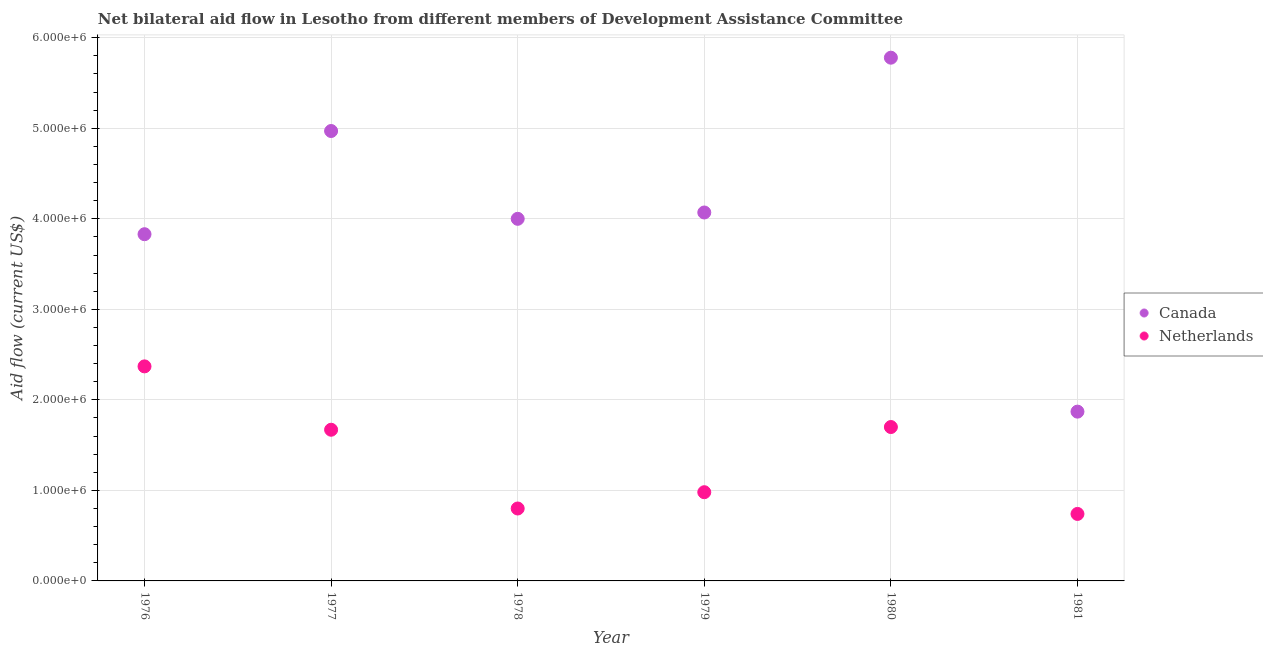How many different coloured dotlines are there?
Give a very brief answer. 2. Is the number of dotlines equal to the number of legend labels?
Your answer should be compact. Yes. What is the amount of aid given by netherlands in 1981?
Offer a very short reply. 7.40e+05. Across all years, what is the maximum amount of aid given by canada?
Your answer should be compact. 5.78e+06. Across all years, what is the minimum amount of aid given by canada?
Offer a very short reply. 1.87e+06. In which year was the amount of aid given by canada maximum?
Your response must be concise. 1980. In which year was the amount of aid given by netherlands minimum?
Your answer should be very brief. 1981. What is the total amount of aid given by netherlands in the graph?
Offer a terse response. 8.26e+06. What is the difference between the amount of aid given by netherlands in 1980 and that in 1981?
Your response must be concise. 9.60e+05. What is the difference between the amount of aid given by netherlands in 1979 and the amount of aid given by canada in 1976?
Provide a succinct answer. -2.85e+06. What is the average amount of aid given by canada per year?
Keep it short and to the point. 4.09e+06. In the year 1978, what is the difference between the amount of aid given by netherlands and amount of aid given by canada?
Your answer should be compact. -3.20e+06. In how many years, is the amount of aid given by canada greater than 4800000 US$?
Make the answer very short. 2. What is the ratio of the amount of aid given by netherlands in 1976 to that in 1979?
Offer a terse response. 2.42. Is the amount of aid given by netherlands in 1977 less than that in 1978?
Your answer should be compact. No. Is the difference between the amount of aid given by canada in 1980 and 1981 greater than the difference between the amount of aid given by netherlands in 1980 and 1981?
Your answer should be very brief. Yes. What is the difference between the highest and the second highest amount of aid given by canada?
Your answer should be very brief. 8.10e+05. What is the difference between the highest and the lowest amount of aid given by canada?
Ensure brevity in your answer.  3.91e+06. Are the values on the major ticks of Y-axis written in scientific E-notation?
Your answer should be compact. Yes. Does the graph contain any zero values?
Your answer should be compact. No. Where does the legend appear in the graph?
Your response must be concise. Center right. How are the legend labels stacked?
Offer a very short reply. Vertical. What is the title of the graph?
Keep it short and to the point. Net bilateral aid flow in Lesotho from different members of Development Assistance Committee. What is the label or title of the X-axis?
Keep it short and to the point. Year. What is the label or title of the Y-axis?
Your response must be concise. Aid flow (current US$). What is the Aid flow (current US$) of Canada in 1976?
Ensure brevity in your answer.  3.83e+06. What is the Aid flow (current US$) of Netherlands in 1976?
Your answer should be very brief. 2.37e+06. What is the Aid flow (current US$) in Canada in 1977?
Your answer should be very brief. 4.97e+06. What is the Aid flow (current US$) in Netherlands in 1977?
Your answer should be very brief. 1.67e+06. What is the Aid flow (current US$) of Canada in 1978?
Provide a succinct answer. 4.00e+06. What is the Aid flow (current US$) in Netherlands in 1978?
Ensure brevity in your answer.  8.00e+05. What is the Aid flow (current US$) in Canada in 1979?
Offer a very short reply. 4.07e+06. What is the Aid flow (current US$) in Netherlands in 1979?
Provide a short and direct response. 9.80e+05. What is the Aid flow (current US$) of Canada in 1980?
Ensure brevity in your answer.  5.78e+06. What is the Aid flow (current US$) in Netherlands in 1980?
Ensure brevity in your answer.  1.70e+06. What is the Aid flow (current US$) of Canada in 1981?
Give a very brief answer. 1.87e+06. What is the Aid flow (current US$) of Netherlands in 1981?
Provide a succinct answer. 7.40e+05. Across all years, what is the maximum Aid flow (current US$) in Canada?
Provide a succinct answer. 5.78e+06. Across all years, what is the maximum Aid flow (current US$) of Netherlands?
Make the answer very short. 2.37e+06. Across all years, what is the minimum Aid flow (current US$) in Canada?
Give a very brief answer. 1.87e+06. Across all years, what is the minimum Aid flow (current US$) in Netherlands?
Provide a short and direct response. 7.40e+05. What is the total Aid flow (current US$) of Canada in the graph?
Offer a very short reply. 2.45e+07. What is the total Aid flow (current US$) in Netherlands in the graph?
Give a very brief answer. 8.26e+06. What is the difference between the Aid flow (current US$) of Canada in 1976 and that in 1977?
Ensure brevity in your answer.  -1.14e+06. What is the difference between the Aid flow (current US$) of Netherlands in 1976 and that in 1977?
Give a very brief answer. 7.00e+05. What is the difference between the Aid flow (current US$) of Netherlands in 1976 and that in 1978?
Your answer should be very brief. 1.57e+06. What is the difference between the Aid flow (current US$) of Netherlands in 1976 and that in 1979?
Your answer should be compact. 1.39e+06. What is the difference between the Aid flow (current US$) in Canada in 1976 and that in 1980?
Make the answer very short. -1.95e+06. What is the difference between the Aid flow (current US$) of Netherlands in 1976 and that in 1980?
Ensure brevity in your answer.  6.70e+05. What is the difference between the Aid flow (current US$) of Canada in 1976 and that in 1981?
Your answer should be very brief. 1.96e+06. What is the difference between the Aid flow (current US$) of Netherlands in 1976 and that in 1981?
Your answer should be very brief. 1.63e+06. What is the difference between the Aid flow (current US$) in Canada in 1977 and that in 1978?
Provide a succinct answer. 9.70e+05. What is the difference between the Aid flow (current US$) in Netherlands in 1977 and that in 1978?
Offer a very short reply. 8.70e+05. What is the difference between the Aid flow (current US$) in Netherlands in 1977 and that in 1979?
Your answer should be very brief. 6.90e+05. What is the difference between the Aid flow (current US$) of Canada in 1977 and that in 1980?
Offer a very short reply. -8.10e+05. What is the difference between the Aid flow (current US$) in Netherlands in 1977 and that in 1980?
Keep it short and to the point. -3.00e+04. What is the difference between the Aid flow (current US$) of Canada in 1977 and that in 1981?
Give a very brief answer. 3.10e+06. What is the difference between the Aid flow (current US$) in Netherlands in 1977 and that in 1981?
Give a very brief answer. 9.30e+05. What is the difference between the Aid flow (current US$) of Canada in 1978 and that in 1979?
Your response must be concise. -7.00e+04. What is the difference between the Aid flow (current US$) in Netherlands in 1978 and that in 1979?
Make the answer very short. -1.80e+05. What is the difference between the Aid flow (current US$) in Canada in 1978 and that in 1980?
Offer a terse response. -1.78e+06. What is the difference between the Aid flow (current US$) in Netherlands in 1978 and that in 1980?
Make the answer very short. -9.00e+05. What is the difference between the Aid flow (current US$) in Canada in 1978 and that in 1981?
Your answer should be compact. 2.13e+06. What is the difference between the Aid flow (current US$) in Canada in 1979 and that in 1980?
Your answer should be compact. -1.71e+06. What is the difference between the Aid flow (current US$) in Netherlands in 1979 and that in 1980?
Offer a very short reply. -7.20e+05. What is the difference between the Aid flow (current US$) in Canada in 1979 and that in 1981?
Give a very brief answer. 2.20e+06. What is the difference between the Aid flow (current US$) of Netherlands in 1979 and that in 1981?
Keep it short and to the point. 2.40e+05. What is the difference between the Aid flow (current US$) of Canada in 1980 and that in 1981?
Your answer should be compact. 3.91e+06. What is the difference between the Aid flow (current US$) of Netherlands in 1980 and that in 1981?
Your answer should be compact. 9.60e+05. What is the difference between the Aid flow (current US$) in Canada in 1976 and the Aid flow (current US$) in Netherlands in 1977?
Your answer should be compact. 2.16e+06. What is the difference between the Aid flow (current US$) in Canada in 1976 and the Aid flow (current US$) in Netherlands in 1978?
Provide a short and direct response. 3.03e+06. What is the difference between the Aid flow (current US$) of Canada in 1976 and the Aid flow (current US$) of Netherlands in 1979?
Your answer should be compact. 2.85e+06. What is the difference between the Aid flow (current US$) of Canada in 1976 and the Aid flow (current US$) of Netherlands in 1980?
Give a very brief answer. 2.13e+06. What is the difference between the Aid flow (current US$) in Canada in 1976 and the Aid flow (current US$) in Netherlands in 1981?
Your answer should be very brief. 3.09e+06. What is the difference between the Aid flow (current US$) in Canada in 1977 and the Aid flow (current US$) in Netherlands in 1978?
Provide a short and direct response. 4.17e+06. What is the difference between the Aid flow (current US$) of Canada in 1977 and the Aid flow (current US$) of Netherlands in 1979?
Give a very brief answer. 3.99e+06. What is the difference between the Aid flow (current US$) in Canada in 1977 and the Aid flow (current US$) in Netherlands in 1980?
Provide a succinct answer. 3.27e+06. What is the difference between the Aid flow (current US$) in Canada in 1977 and the Aid flow (current US$) in Netherlands in 1981?
Make the answer very short. 4.23e+06. What is the difference between the Aid flow (current US$) in Canada in 1978 and the Aid flow (current US$) in Netherlands in 1979?
Offer a terse response. 3.02e+06. What is the difference between the Aid flow (current US$) in Canada in 1978 and the Aid flow (current US$) in Netherlands in 1980?
Your answer should be compact. 2.30e+06. What is the difference between the Aid flow (current US$) in Canada in 1978 and the Aid flow (current US$) in Netherlands in 1981?
Your answer should be compact. 3.26e+06. What is the difference between the Aid flow (current US$) in Canada in 1979 and the Aid flow (current US$) in Netherlands in 1980?
Your answer should be very brief. 2.37e+06. What is the difference between the Aid flow (current US$) of Canada in 1979 and the Aid flow (current US$) of Netherlands in 1981?
Give a very brief answer. 3.33e+06. What is the difference between the Aid flow (current US$) of Canada in 1980 and the Aid flow (current US$) of Netherlands in 1981?
Provide a short and direct response. 5.04e+06. What is the average Aid flow (current US$) in Canada per year?
Give a very brief answer. 4.09e+06. What is the average Aid flow (current US$) of Netherlands per year?
Ensure brevity in your answer.  1.38e+06. In the year 1976, what is the difference between the Aid flow (current US$) of Canada and Aid flow (current US$) of Netherlands?
Your response must be concise. 1.46e+06. In the year 1977, what is the difference between the Aid flow (current US$) of Canada and Aid flow (current US$) of Netherlands?
Keep it short and to the point. 3.30e+06. In the year 1978, what is the difference between the Aid flow (current US$) in Canada and Aid flow (current US$) in Netherlands?
Provide a short and direct response. 3.20e+06. In the year 1979, what is the difference between the Aid flow (current US$) of Canada and Aid flow (current US$) of Netherlands?
Provide a short and direct response. 3.09e+06. In the year 1980, what is the difference between the Aid flow (current US$) in Canada and Aid flow (current US$) in Netherlands?
Provide a succinct answer. 4.08e+06. In the year 1981, what is the difference between the Aid flow (current US$) of Canada and Aid flow (current US$) of Netherlands?
Your response must be concise. 1.13e+06. What is the ratio of the Aid flow (current US$) of Canada in 1976 to that in 1977?
Offer a very short reply. 0.77. What is the ratio of the Aid flow (current US$) of Netherlands in 1976 to that in 1977?
Provide a short and direct response. 1.42. What is the ratio of the Aid flow (current US$) in Canada in 1976 to that in 1978?
Offer a very short reply. 0.96. What is the ratio of the Aid flow (current US$) of Netherlands in 1976 to that in 1978?
Ensure brevity in your answer.  2.96. What is the ratio of the Aid flow (current US$) of Canada in 1976 to that in 1979?
Ensure brevity in your answer.  0.94. What is the ratio of the Aid flow (current US$) of Netherlands in 1976 to that in 1979?
Your answer should be very brief. 2.42. What is the ratio of the Aid flow (current US$) in Canada in 1976 to that in 1980?
Your answer should be very brief. 0.66. What is the ratio of the Aid flow (current US$) in Netherlands in 1976 to that in 1980?
Ensure brevity in your answer.  1.39. What is the ratio of the Aid flow (current US$) in Canada in 1976 to that in 1981?
Give a very brief answer. 2.05. What is the ratio of the Aid flow (current US$) of Netherlands in 1976 to that in 1981?
Your answer should be compact. 3.2. What is the ratio of the Aid flow (current US$) of Canada in 1977 to that in 1978?
Keep it short and to the point. 1.24. What is the ratio of the Aid flow (current US$) of Netherlands in 1977 to that in 1978?
Provide a succinct answer. 2.09. What is the ratio of the Aid flow (current US$) in Canada in 1977 to that in 1979?
Keep it short and to the point. 1.22. What is the ratio of the Aid flow (current US$) in Netherlands in 1977 to that in 1979?
Your response must be concise. 1.7. What is the ratio of the Aid flow (current US$) in Canada in 1977 to that in 1980?
Provide a succinct answer. 0.86. What is the ratio of the Aid flow (current US$) in Netherlands in 1977 to that in 1980?
Give a very brief answer. 0.98. What is the ratio of the Aid flow (current US$) in Canada in 1977 to that in 1981?
Keep it short and to the point. 2.66. What is the ratio of the Aid flow (current US$) of Netherlands in 1977 to that in 1981?
Your answer should be very brief. 2.26. What is the ratio of the Aid flow (current US$) of Canada in 1978 to that in 1979?
Offer a terse response. 0.98. What is the ratio of the Aid flow (current US$) of Netherlands in 1978 to that in 1979?
Offer a very short reply. 0.82. What is the ratio of the Aid flow (current US$) in Canada in 1978 to that in 1980?
Ensure brevity in your answer.  0.69. What is the ratio of the Aid flow (current US$) in Netherlands in 1978 to that in 1980?
Your response must be concise. 0.47. What is the ratio of the Aid flow (current US$) in Canada in 1978 to that in 1981?
Make the answer very short. 2.14. What is the ratio of the Aid flow (current US$) in Netherlands in 1978 to that in 1981?
Your answer should be compact. 1.08. What is the ratio of the Aid flow (current US$) of Canada in 1979 to that in 1980?
Your answer should be very brief. 0.7. What is the ratio of the Aid flow (current US$) of Netherlands in 1979 to that in 1980?
Make the answer very short. 0.58. What is the ratio of the Aid flow (current US$) in Canada in 1979 to that in 1981?
Provide a succinct answer. 2.18. What is the ratio of the Aid flow (current US$) of Netherlands in 1979 to that in 1981?
Provide a short and direct response. 1.32. What is the ratio of the Aid flow (current US$) of Canada in 1980 to that in 1981?
Offer a very short reply. 3.09. What is the ratio of the Aid flow (current US$) of Netherlands in 1980 to that in 1981?
Provide a succinct answer. 2.3. What is the difference between the highest and the second highest Aid flow (current US$) of Canada?
Make the answer very short. 8.10e+05. What is the difference between the highest and the second highest Aid flow (current US$) of Netherlands?
Your answer should be very brief. 6.70e+05. What is the difference between the highest and the lowest Aid flow (current US$) in Canada?
Keep it short and to the point. 3.91e+06. What is the difference between the highest and the lowest Aid flow (current US$) in Netherlands?
Ensure brevity in your answer.  1.63e+06. 